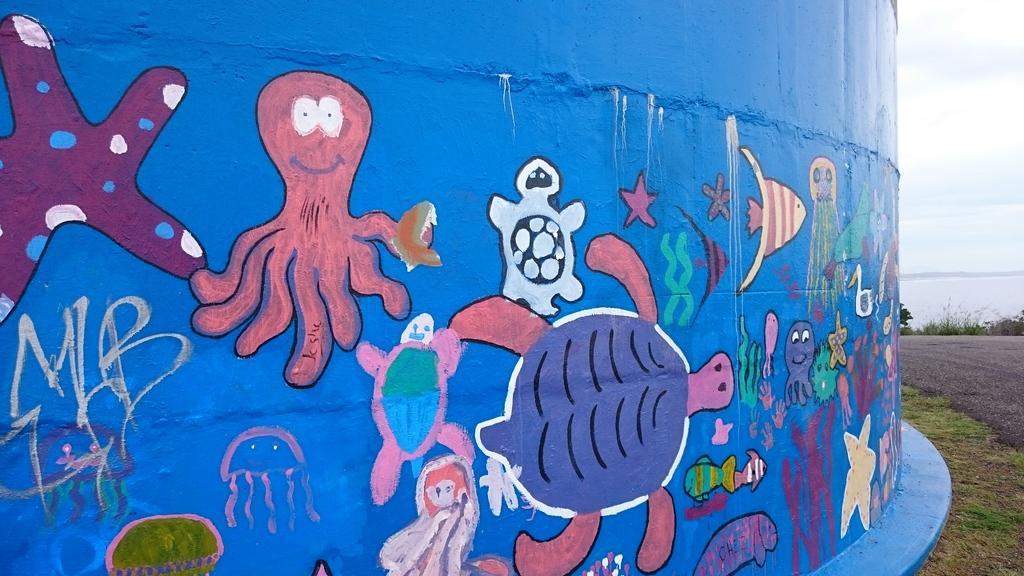Describe this image in one or two sentences. In this image, we can see the blue colored wall with some art. We can also see some water and the sky. We can see some plants and grass. 